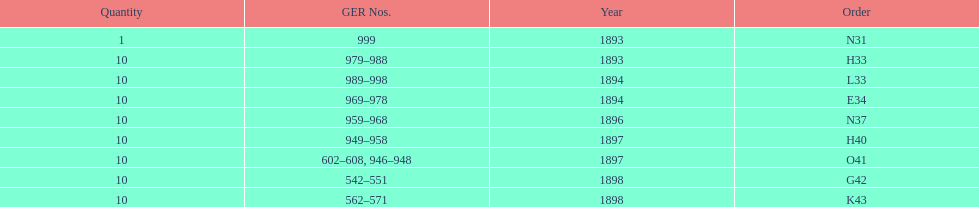What order is listed first at the top of the table? N31. 